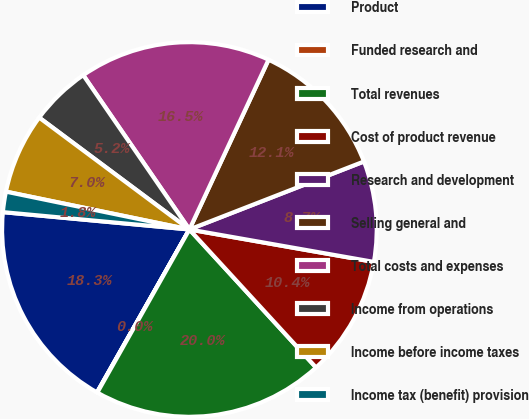Convert chart to OTSL. <chart><loc_0><loc_0><loc_500><loc_500><pie_chart><fcel>Product<fcel>Funded research and<fcel>Total revenues<fcel>Cost of product revenue<fcel>Research and development<fcel>Selling general and<fcel>Total costs and expenses<fcel>Income from operations<fcel>Income before income taxes<fcel>Income tax (benefit) provision<nl><fcel>18.26%<fcel>0.03%<fcel>19.99%<fcel>10.41%<fcel>8.68%<fcel>12.14%<fcel>16.53%<fcel>5.22%<fcel>6.95%<fcel>1.76%<nl></chart> 